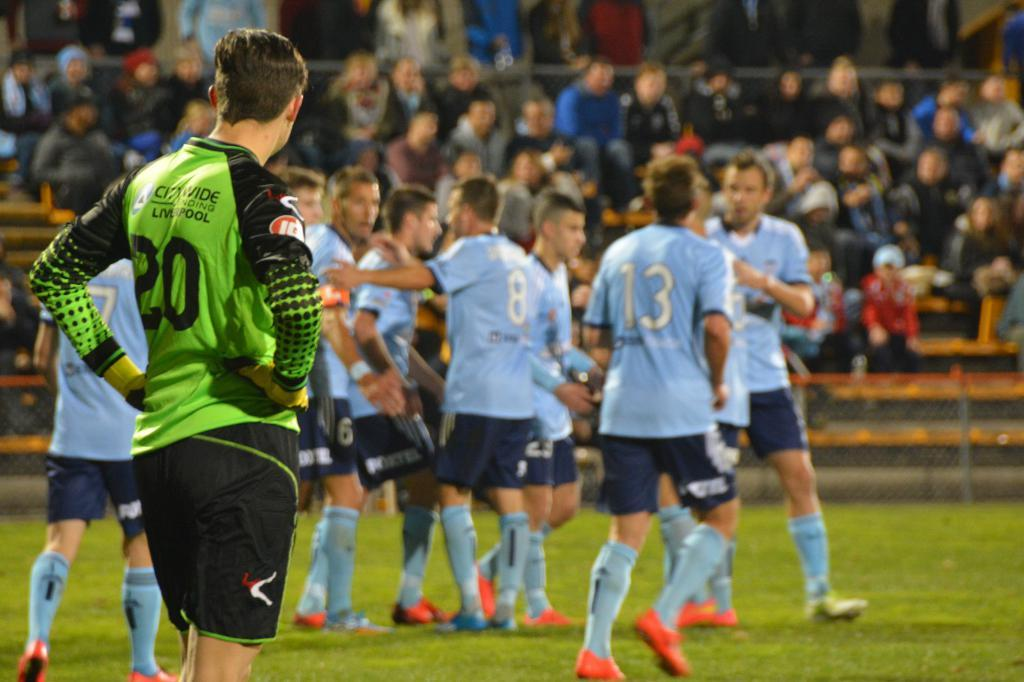<image>
Create a compact narrative representing the image presented. One of the several soccer players has the number 8 on his back 